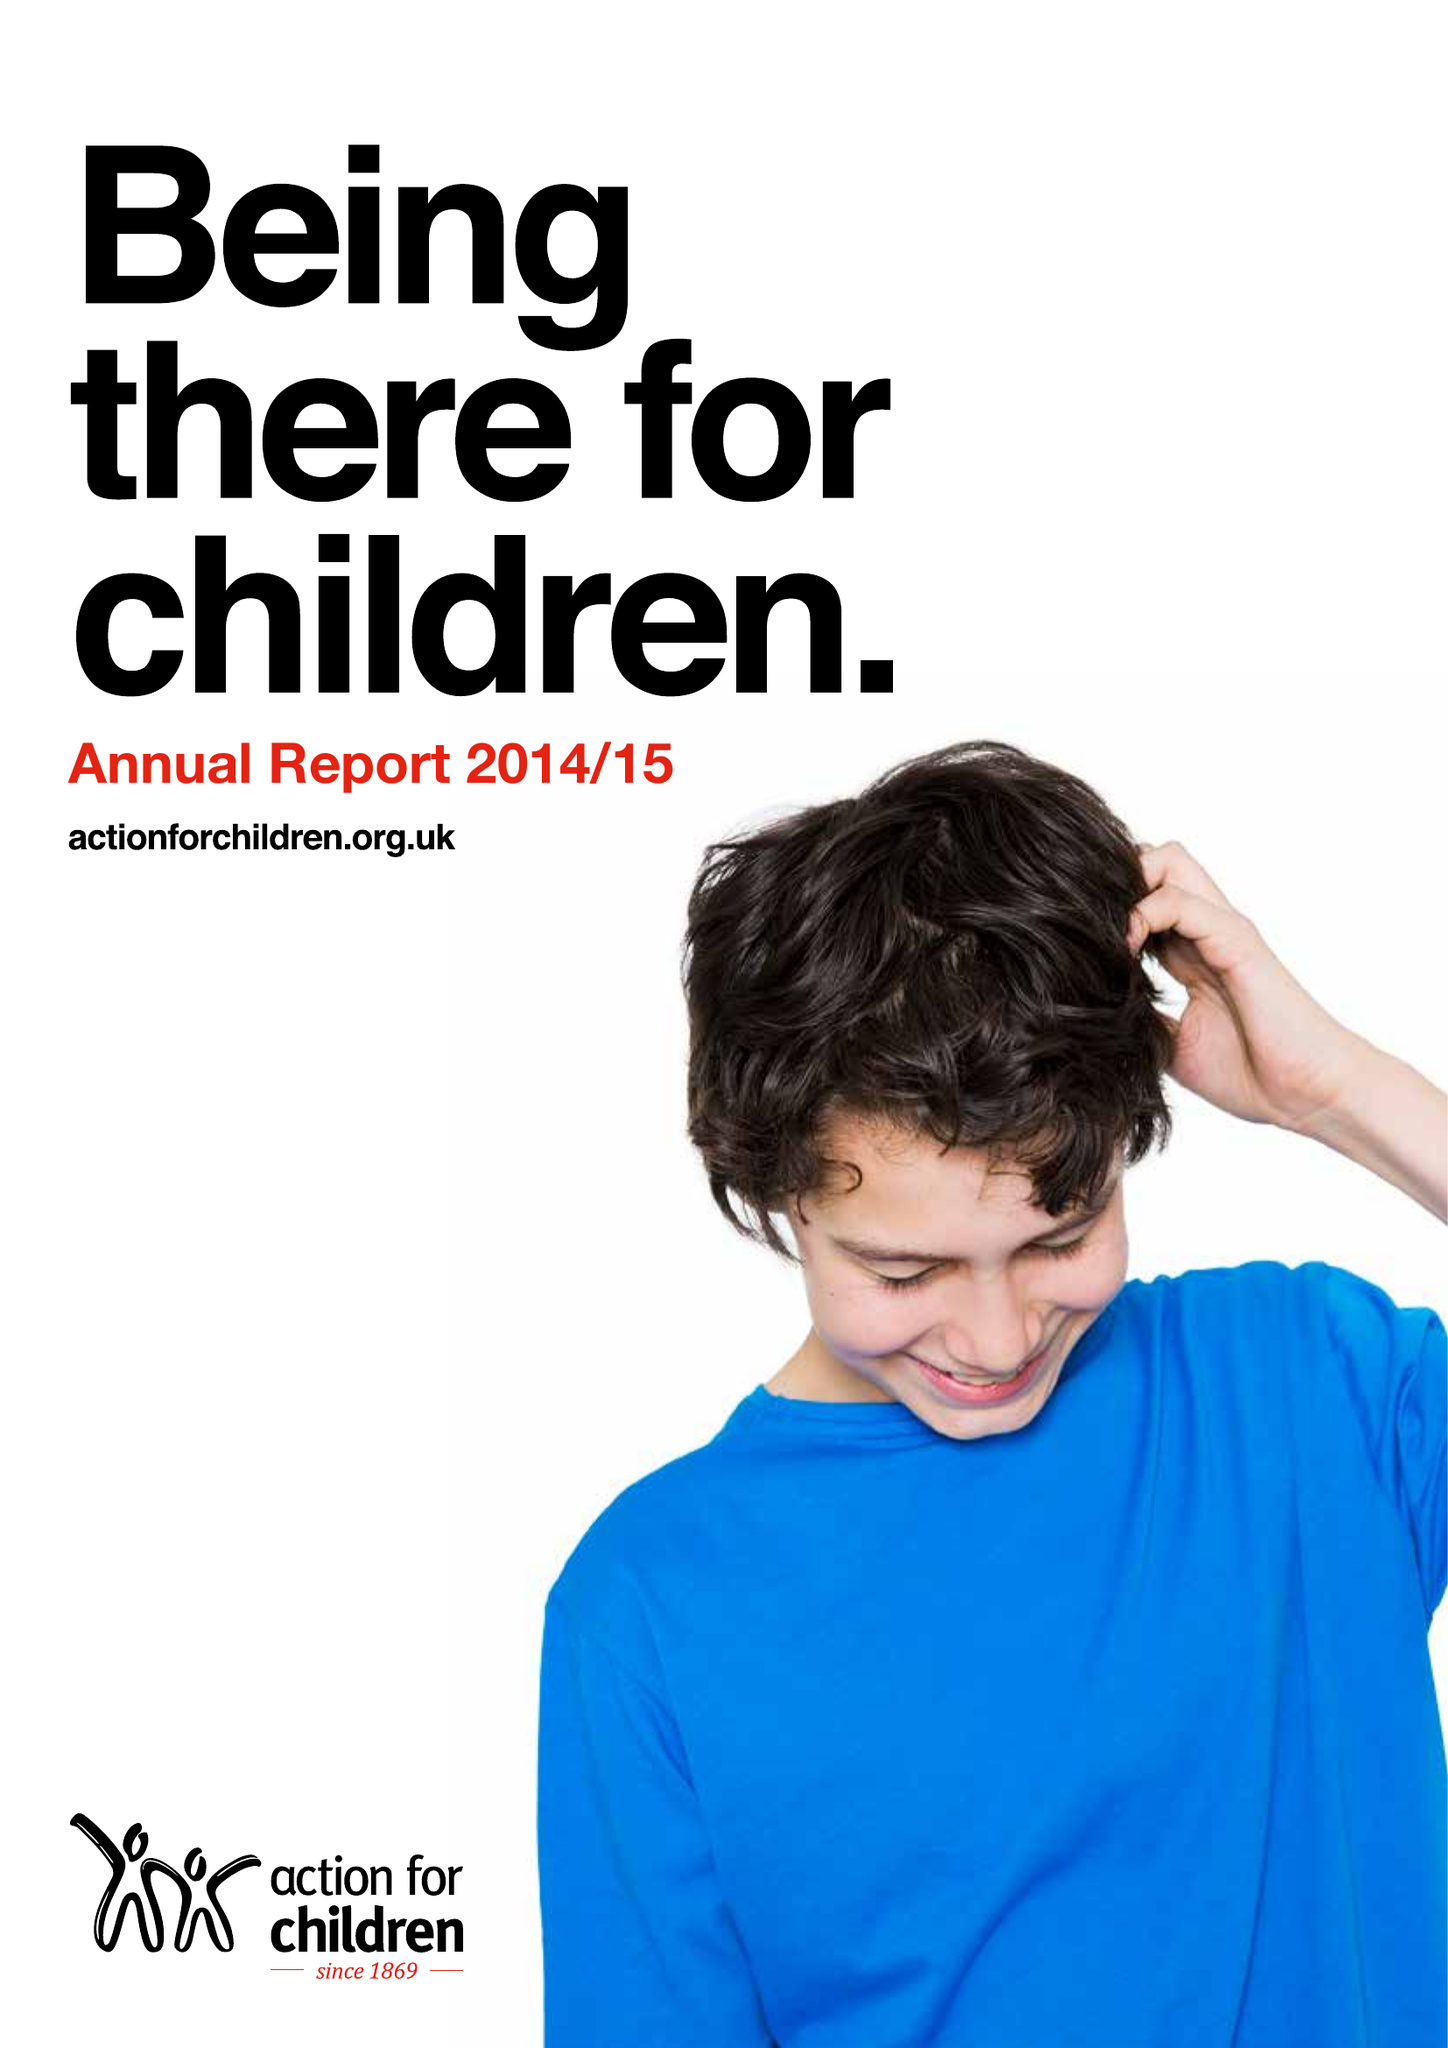What is the value for the spending_annually_in_british_pounds?
Answer the question using a single word or phrase. 159887000.00 